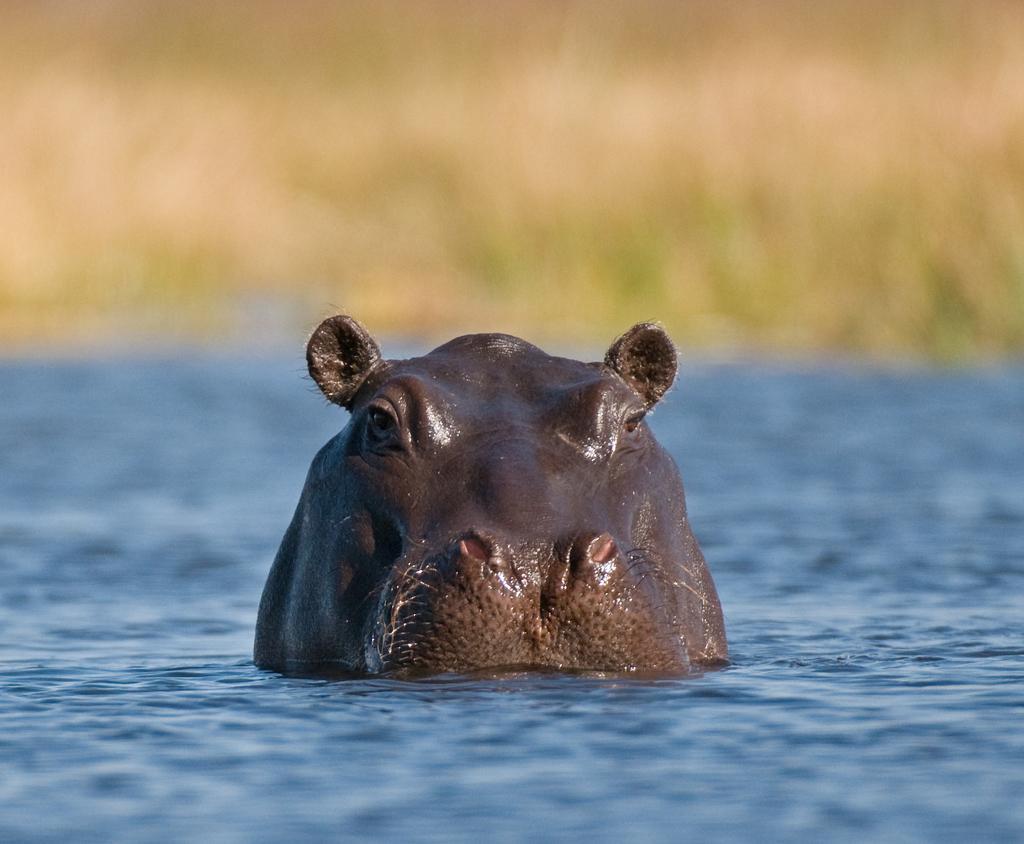Can you describe this image briefly? In this image we can see an animal in the water and the background is blurred. 